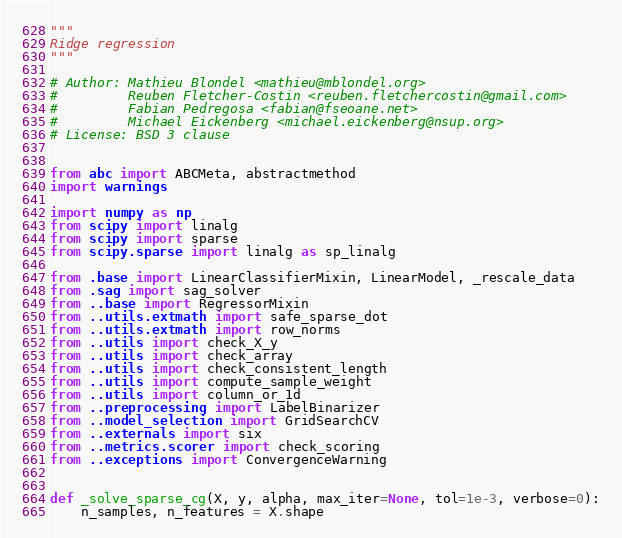<code> <loc_0><loc_0><loc_500><loc_500><_Python_>"""
Ridge regression
"""

# Author: Mathieu Blondel <mathieu@mblondel.org>
#         Reuben Fletcher-Costin <reuben.fletchercostin@gmail.com>
#         Fabian Pedregosa <fabian@fseoane.net>
#         Michael Eickenberg <michael.eickenberg@nsup.org>
# License: BSD 3 clause


from abc import ABCMeta, abstractmethod
import warnings

import numpy as np
from scipy import linalg
from scipy import sparse
from scipy.sparse import linalg as sp_linalg

from .base import LinearClassifierMixin, LinearModel, _rescale_data
from .sag import sag_solver
from ..base import RegressorMixin
from ..utils.extmath import safe_sparse_dot
from ..utils.extmath import row_norms
from ..utils import check_X_y
from ..utils import check_array
from ..utils import check_consistent_length
from ..utils import compute_sample_weight
from ..utils import column_or_1d
from ..preprocessing import LabelBinarizer
from ..model_selection import GridSearchCV
from ..externals import six
from ..metrics.scorer import check_scoring
from ..exceptions import ConvergenceWarning


def _solve_sparse_cg(X, y, alpha, max_iter=None, tol=1e-3, verbose=0):
    n_samples, n_features = X.shape</code> 